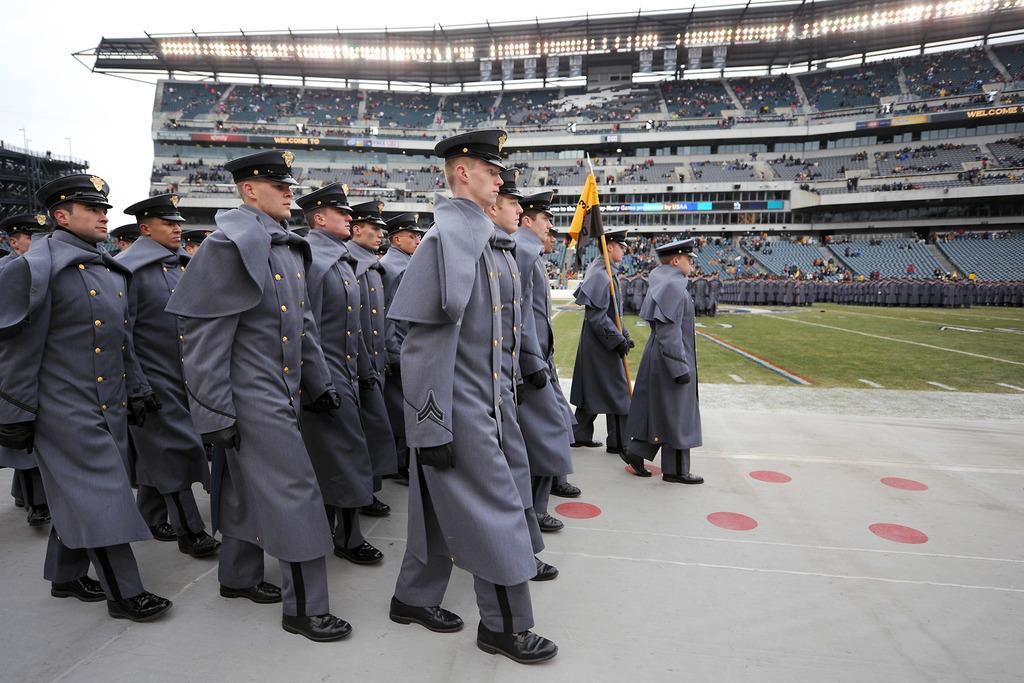In one or two sentences, can you explain what this image depicts? In this image I can see groups of people walking on the ground in which one of them is holding the flag, beside them there are another group of people standing also there are so many people at the stadium. 